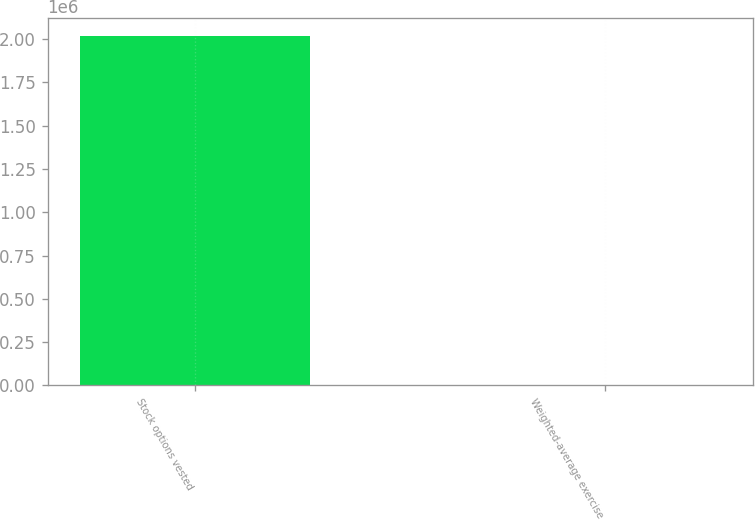<chart> <loc_0><loc_0><loc_500><loc_500><bar_chart><fcel>Stock options vested<fcel>Weighted-average exercise<nl><fcel>2.02005e+06<fcel>40.8<nl></chart> 